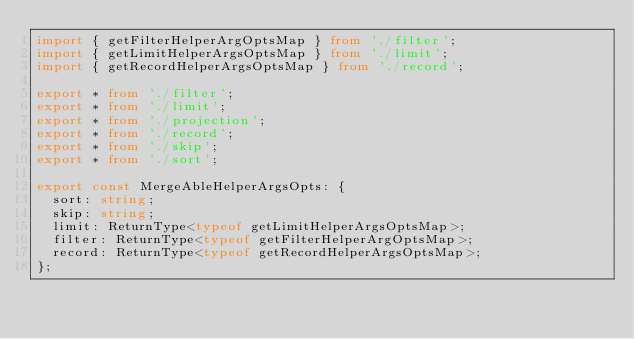<code> <loc_0><loc_0><loc_500><loc_500><_TypeScript_>import { getFilterHelperArgOptsMap } from './filter';
import { getLimitHelperArgsOptsMap } from './limit';
import { getRecordHelperArgsOptsMap } from './record';

export * from './filter';
export * from './limit';
export * from './projection';
export * from './record';
export * from './skip';
export * from './sort';

export const MergeAbleHelperArgsOpts: {
  sort: string;
  skip: string;
  limit: ReturnType<typeof getLimitHelperArgsOptsMap>;
  filter: ReturnType<typeof getFilterHelperArgOptsMap>;
  record: ReturnType<typeof getRecordHelperArgsOptsMap>;
};
</code> 